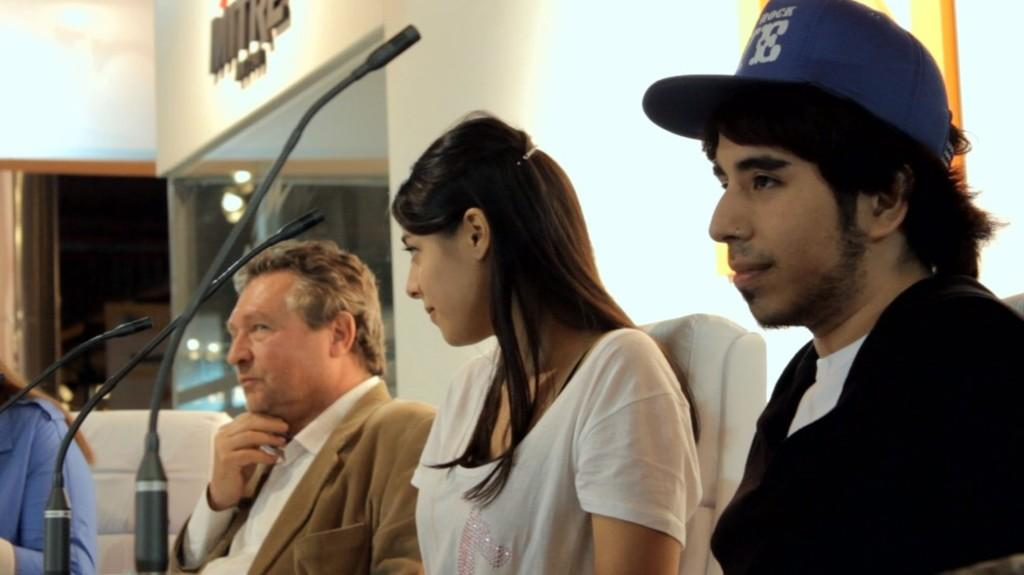How many people are present in the image? There are four people in the image. What are the people doing in the image? The people are sitting on chairs. What objects are in front of the people? There are microphones in front of the people. What can be seen in the background of the image? There is a wall in the background of the image. What type of stamp can be seen on the pocket of the person on the left? There is no stamp or pocket visible on any person in the image. 